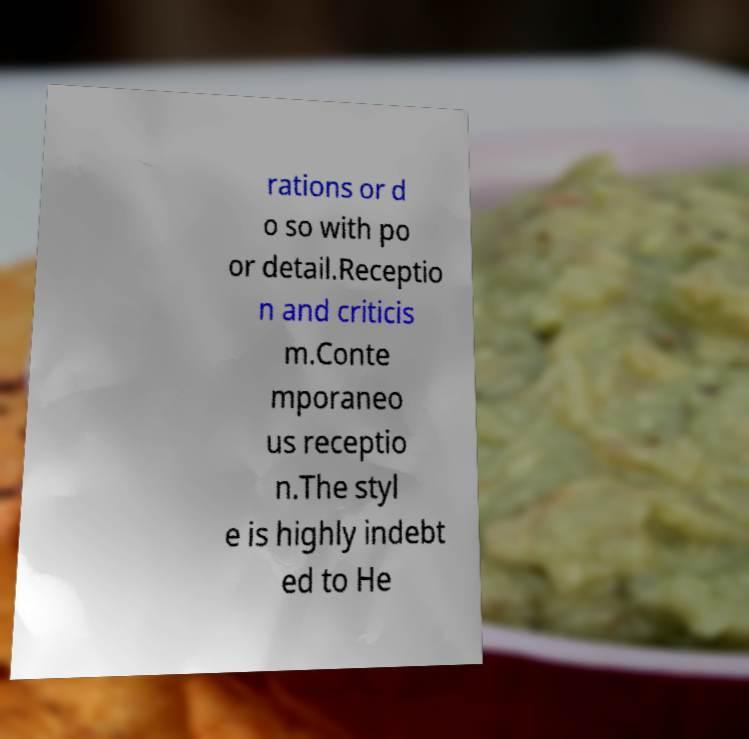Please read and relay the text visible in this image. What does it say? rations or d o so with po or detail.Receptio n and criticis m.Conte mporaneo us receptio n.The styl e is highly indebt ed to He 